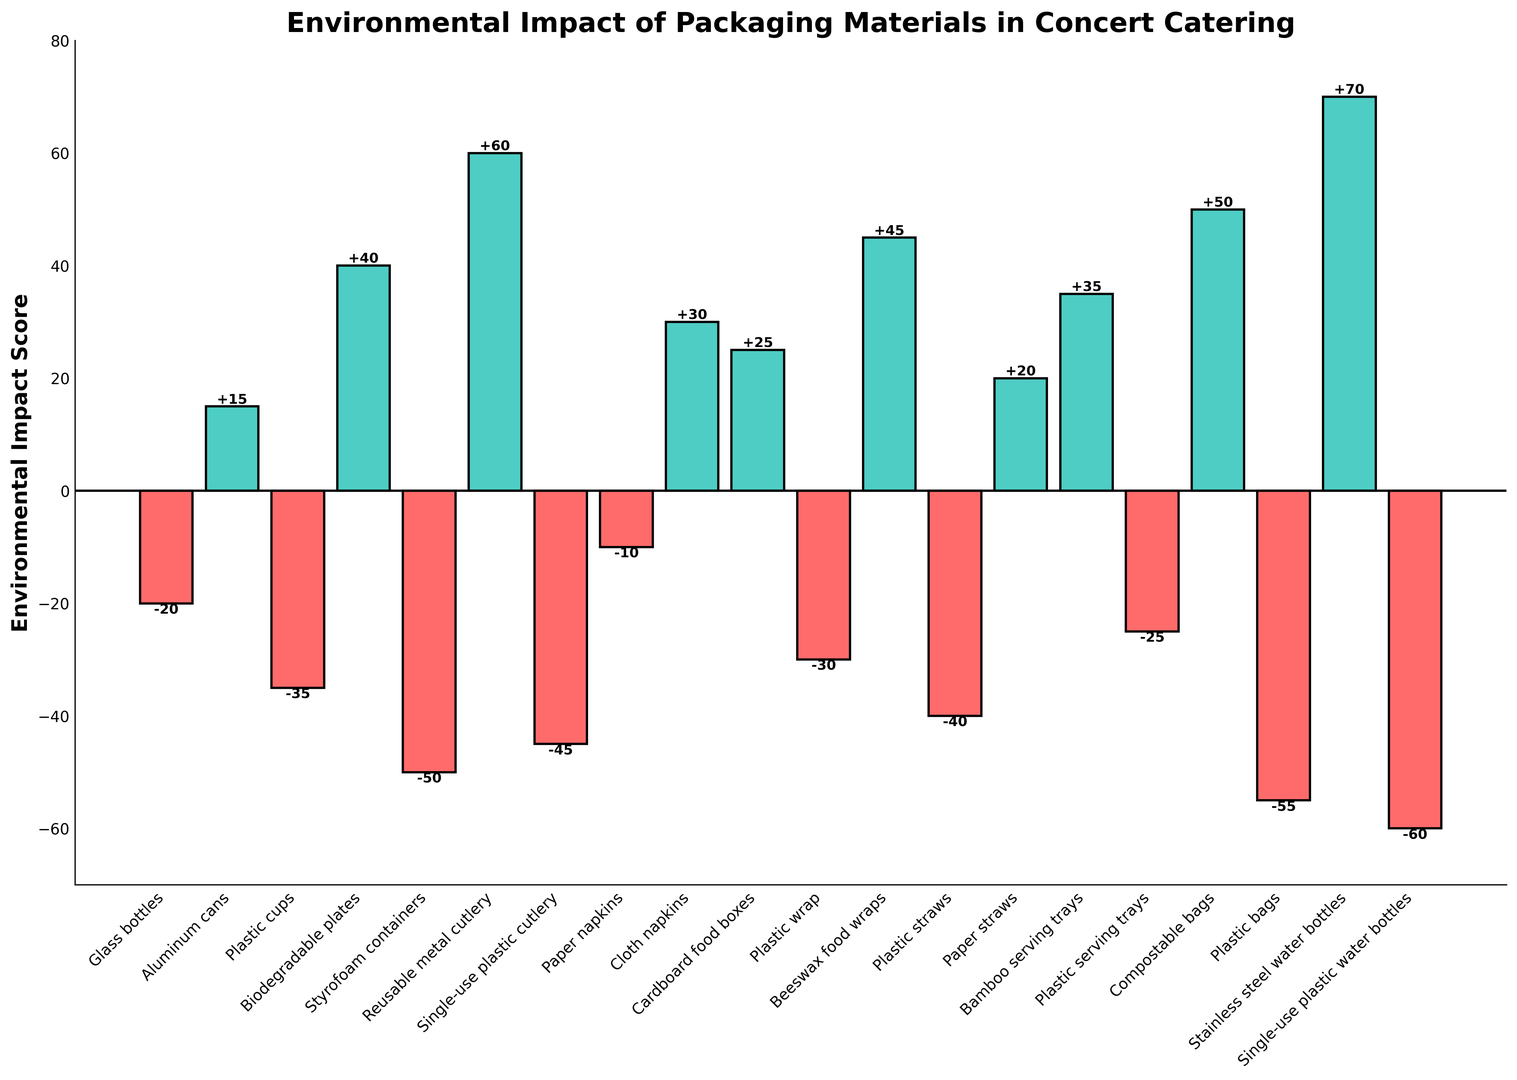What material has the highest positive environmental impact score? The bar chart shows Stainless steel water bottles with the highest bar in the positive direction, representing the most significant environmental impact score.
Answer: Stainless steel water bottles What material has the most negative environmental impact score? By looking at the lowest bar in the negative direction, Single-use plastic water bottles have the most negative environmental impact score.
Answer: Single-use plastic water bottles Which material has a higher environmental impact score: Cloth napkins or Beeswax food wraps? Beeswax food wraps have a bar that goes up to 45, whereas Cloth napkins have a bar that goes up to 30. Thus, Beeswax food wraps have a higher score.
Answer: Beeswax food wraps What is the total positive environmental impact score of Reusable metal cutlery and Compostable bags? Reusable metal cutlery has a score of 60 and Compostable bags have a score of 50. Adding them together results in 60 + 50 = 110.
Answer: 110 How does the environmental impact of Plastic bags compare to Paper napkins? Plastic bags have a significantly lower environmental impact score (-55) compared to Paper napkins (-10), indicating a more negative effect.
Answer: Plastic bags are worse Which materials have positive environmental impact scores? By observing the bars in the positive direction, the materials are Aluminum cans, Biodegradable plates, Reusable metal cutlery, Cloth napkins, Cardboard food boxes, Paper straws, Bamboo serving trays, Beeswax food wraps, Compostable bags, and Stainless steel water bottles.
Answer: Aluminum cans, Biodegradable plates, Reusable metal cutlery, Cloth napkins, Cardboard food boxes, Paper straws, Bamboo serving trays, Beeswax food wraps, Compostable bags, Stainless steel water bottles What is the sum of the environmental impact scores of Paper straws and Aluminum cans? Paper straws have a score of 20, and Aluminum cans have a score of 15. Adding these values together results in 20 + 15 = 35.
Answer: 35 